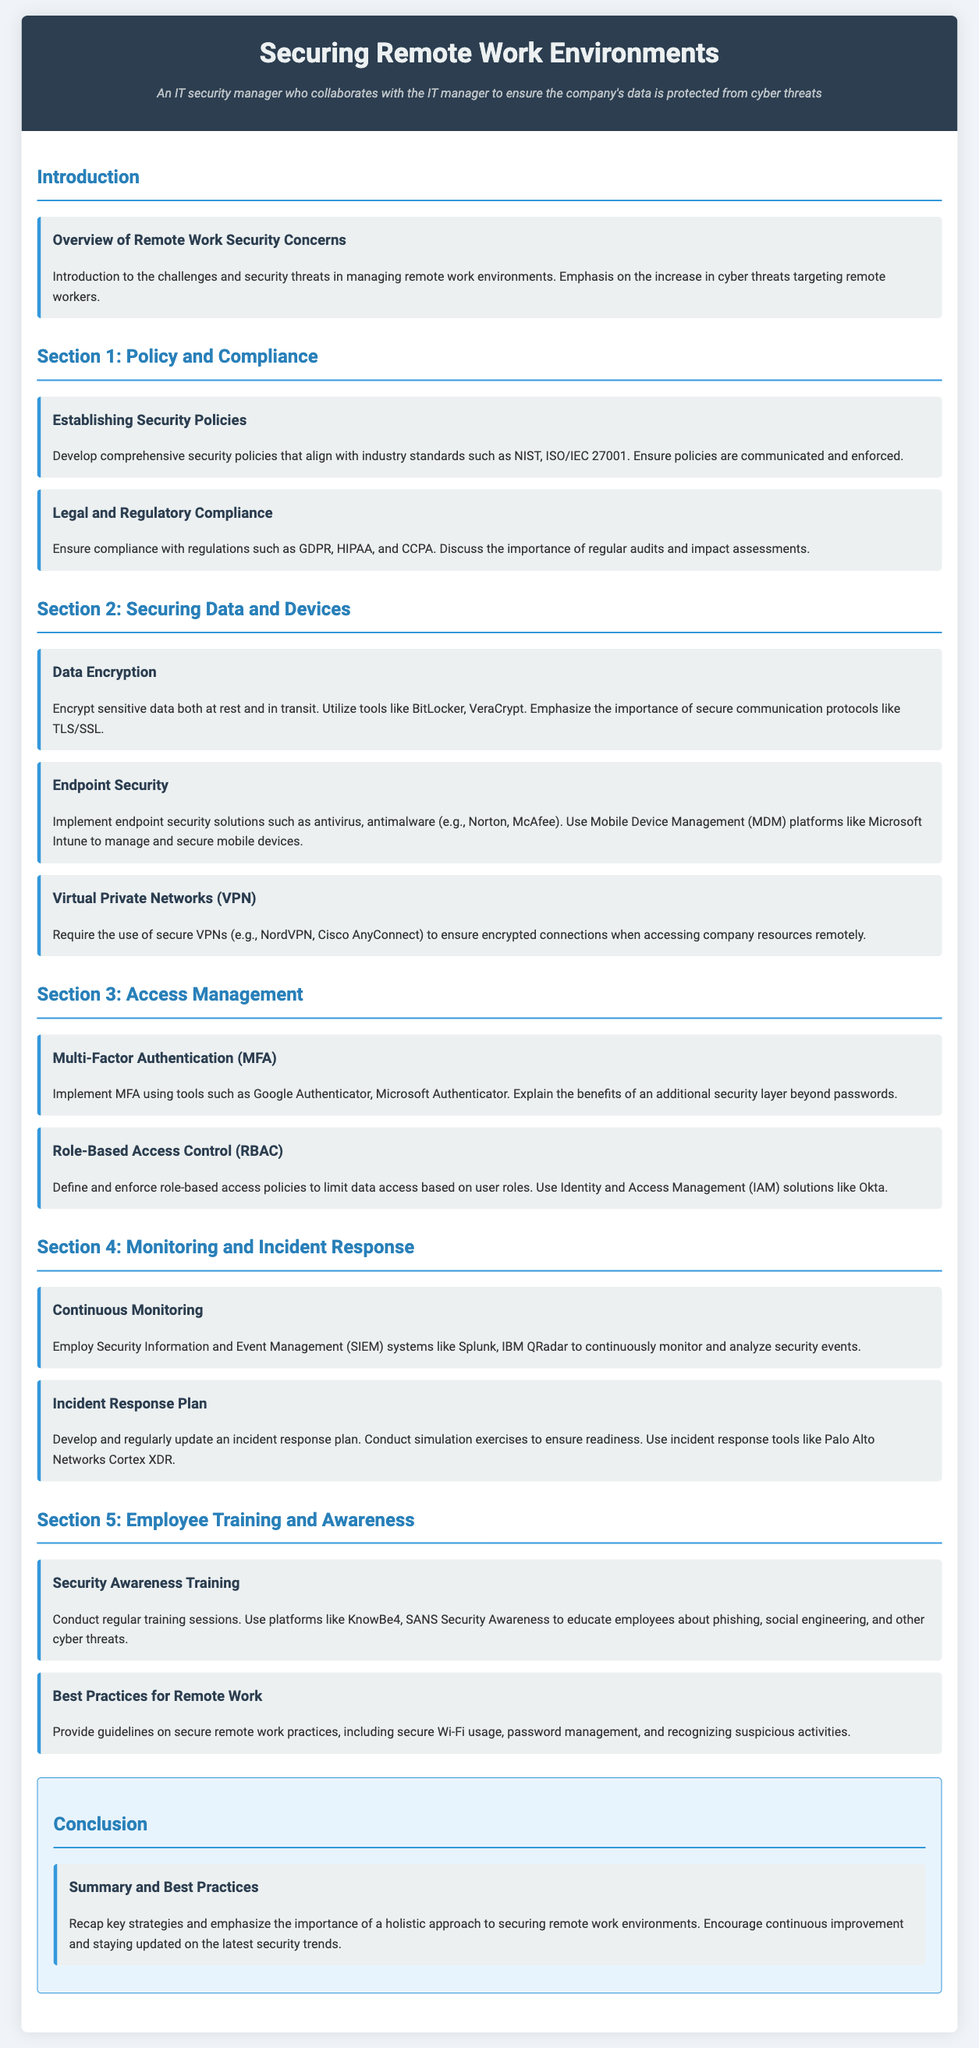What is the title of the lesson plan? The title is stated in the document's header as the main subject of the lesson plan.
Answer: Securing Remote Work Environments What security standard is mentioned in establishing security policies? The document discusses aligning security policies with industry standards, specifically mentioning one standard.
Answer: NIST What legal regulation is highlighted for compliance? The section on legal compliance mentions specific regulations that organizations need to follow; one of them is noted in the document.
Answer: GDPR Which tool is suggested for implementing Multi-Factor Authentication? The document lists specific tools that can be used for MFA, referring to their ability to enhance security.
Answer: Google Authenticator What is one recommended endpoint security solution? The document includes different solutions for endpoint security in the relevant section; one example is clearly mentioned.
Answer: Norton What does SIEM stand for? The section on continuous monitoring mentions an abbreviation that represents a type of system used in security management.
Answer: Security Information and Event Management How often should security awareness training be conducted? The document suggests a frequency for conducting training sessions to educate employees, indicating an ongoing need.
Answer: Regularly What is the purpose of an incident response plan? The document describes a specific purpose for having an incident response plan as part of security measures.
Answer: Preparedness What should remote employees secure while working? The document highlights a specific aspect of remote work practices that employees need to focus on to maintain security.
Answer: Wi-Fi 